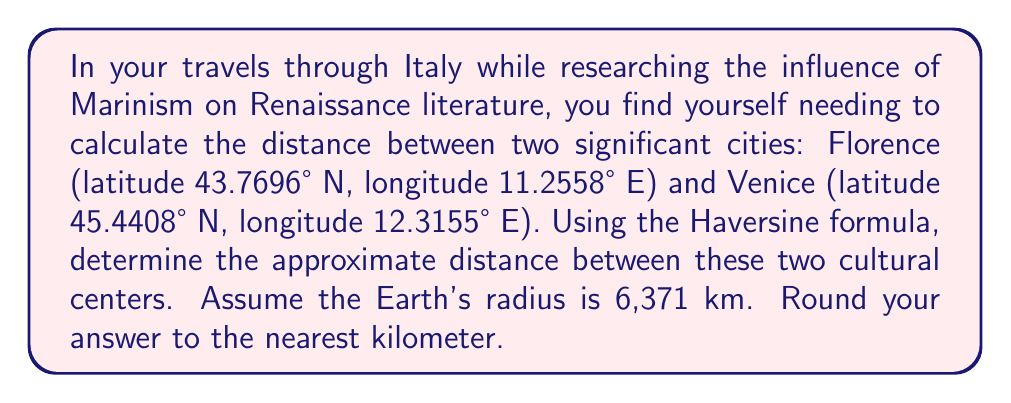Could you help me with this problem? To calculate the distance between Florence and Venice using their latitude and longitude coordinates, we'll use the Haversine formula. This formula is particularly useful for calculating distances on a sphere, such as Earth.

Let's define our variables:
$\phi_1, \lambda_1$: latitude and longitude of Florence
$\phi_2, \lambda_2$: latitude and longitude of Venice
$R$: Earth's radius (6,371 km)

Step 1: Convert degrees to radians
$\phi_1 = 43.7696° \times \frac{\pi}{180} = 0.7639$ radians
$\lambda_1 = 11.2558° \times \frac{\pi}{180} = 0.1964$ radians
$\phi_2 = 45.4408° \times \frac{\pi}{180} = 0.7929$ radians
$\lambda_2 = 12.3155° \times \frac{\pi}{180} = 0.2150$ radians

Step 2: Calculate the differences
$\Delta\phi = \phi_2 - \phi_1 = 0.7929 - 0.7639 = 0.0290$ radians
$\Delta\lambda = \lambda_2 - \lambda_1 = 0.2150 - 0.1964 = 0.0186$ radians

Step 3: Apply the Haversine formula
$$a = \sin^2(\frac{\Delta\phi}{2}) + \cos(\phi_1) \cos(\phi_2) \sin^2(\frac{\Delta\lambda}{2})$$
$$c = 2 \arctan2(\sqrt{a}, \sqrt{1-a})$$
$$d = R \times c$$

Calculating $a$:
$a = \sin^2(0.0145) + \cos(0.7639) \cos(0.7929) \sin^2(0.0093)$
$a = 0.0002 + 0.7180 \times 0.7010 \times 0.0001 = 0.0002$

Calculating $c$:
$c = 2 \arctan2(\sqrt{0.0002}, \sqrt{1-0.0002}) = 0.0283$

Finally, calculating the distance $d$:
$d = 6371 \times 0.0283 = 180.30$ km

Rounding to the nearest kilometer, we get 180 km.
Answer: 180 km 